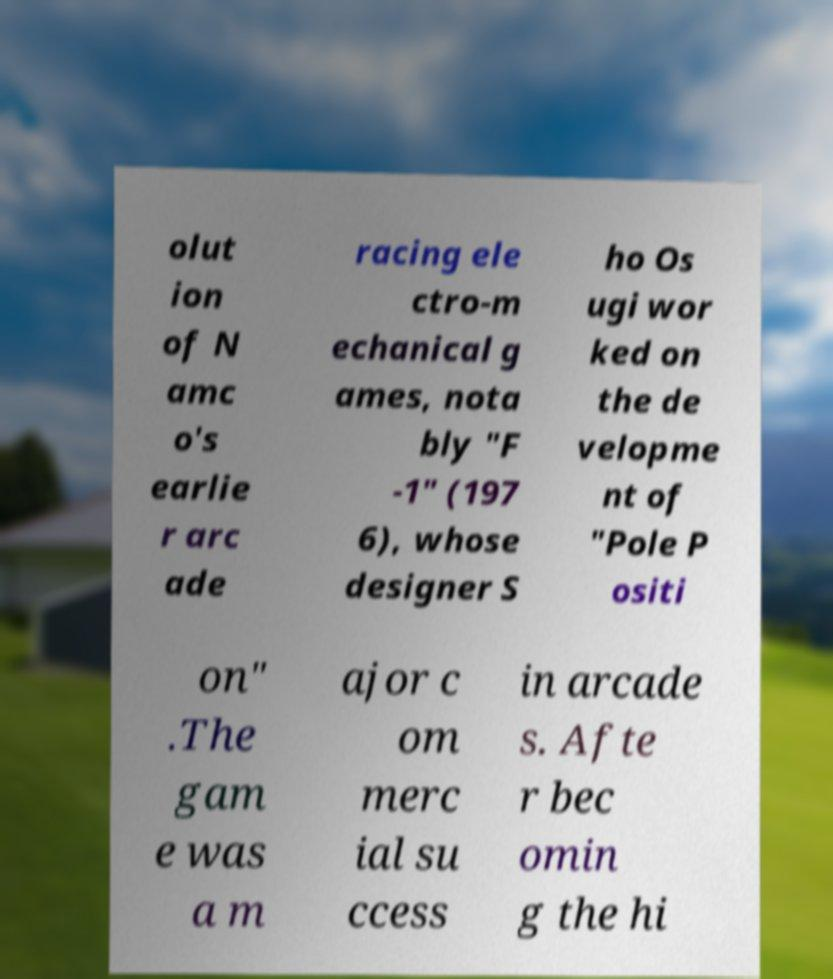Can you read and provide the text displayed in the image?This photo seems to have some interesting text. Can you extract and type it out for me? olut ion of N amc o's earlie r arc ade racing ele ctro-m echanical g ames, nota bly "F -1" (197 6), whose designer S ho Os ugi wor ked on the de velopme nt of "Pole P ositi on" .The gam e was a m ajor c om merc ial su ccess in arcade s. Afte r bec omin g the hi 